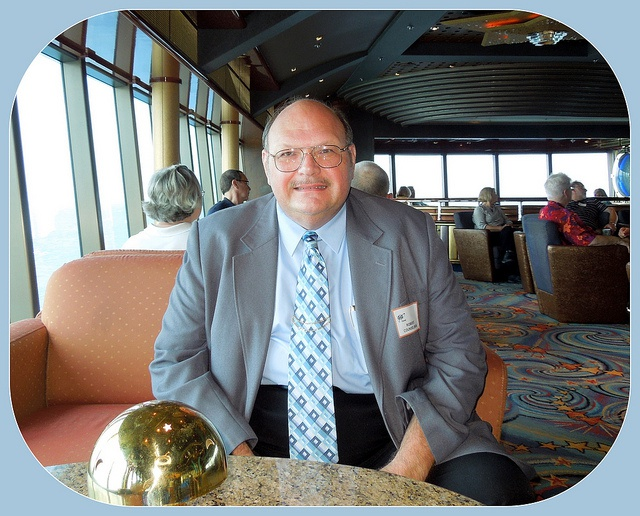Describe the objects in this image and their specific colors. I can see people in lightblue, gray, black, and lightgray tones, couch in lightblue, tan, maroon, and salmon tones, chair in lightblue, black, and blue tones, tie in lightblue and gray tones, and people in lightblue, white, gray, darkgray, and black tones in this image. 